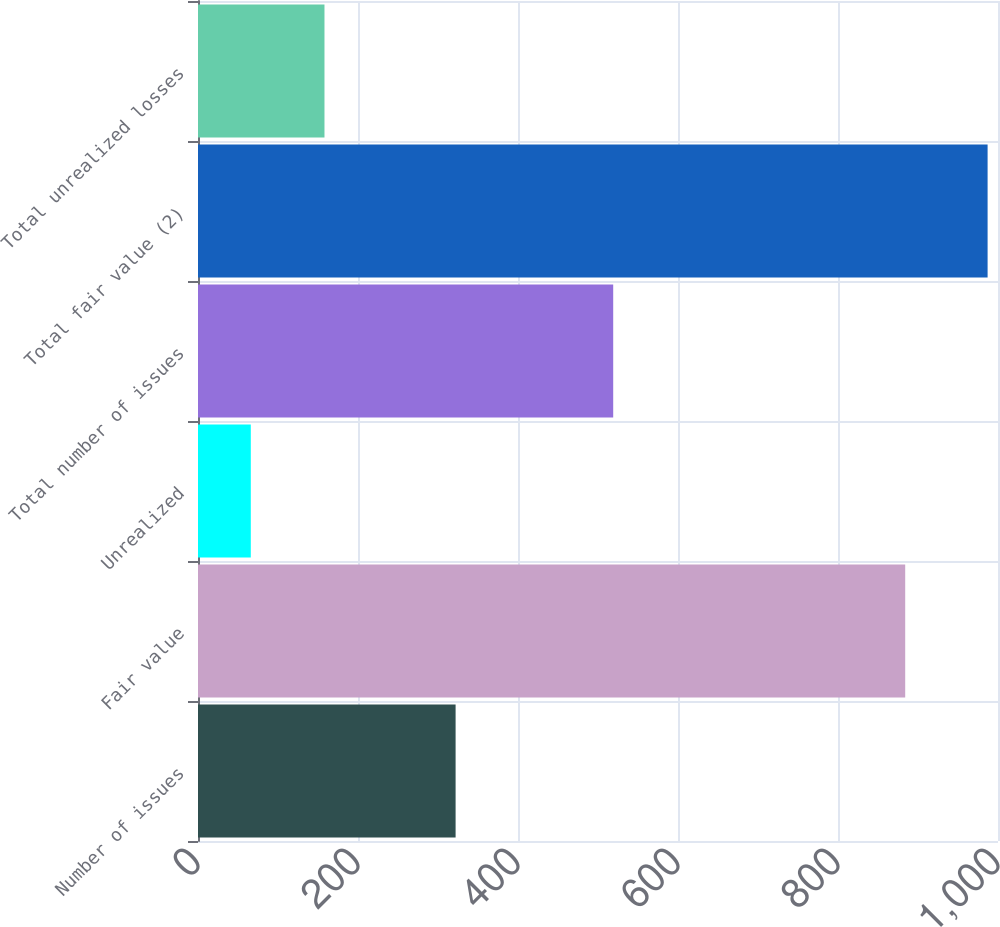<chart> <loc_0><loc_0><loc_500><loc_500><bar_chart><fcel>Number of issues<fcel>Fair value<fcel>Unrealized<fcel>Total number of issues<fcel>Total fair value (2)<fcel>Total unrealized losses<nl><fcel>322<fcel>884<fcel>66<fcel>519<fcel>987<fcel>158.1<nl></chart> 